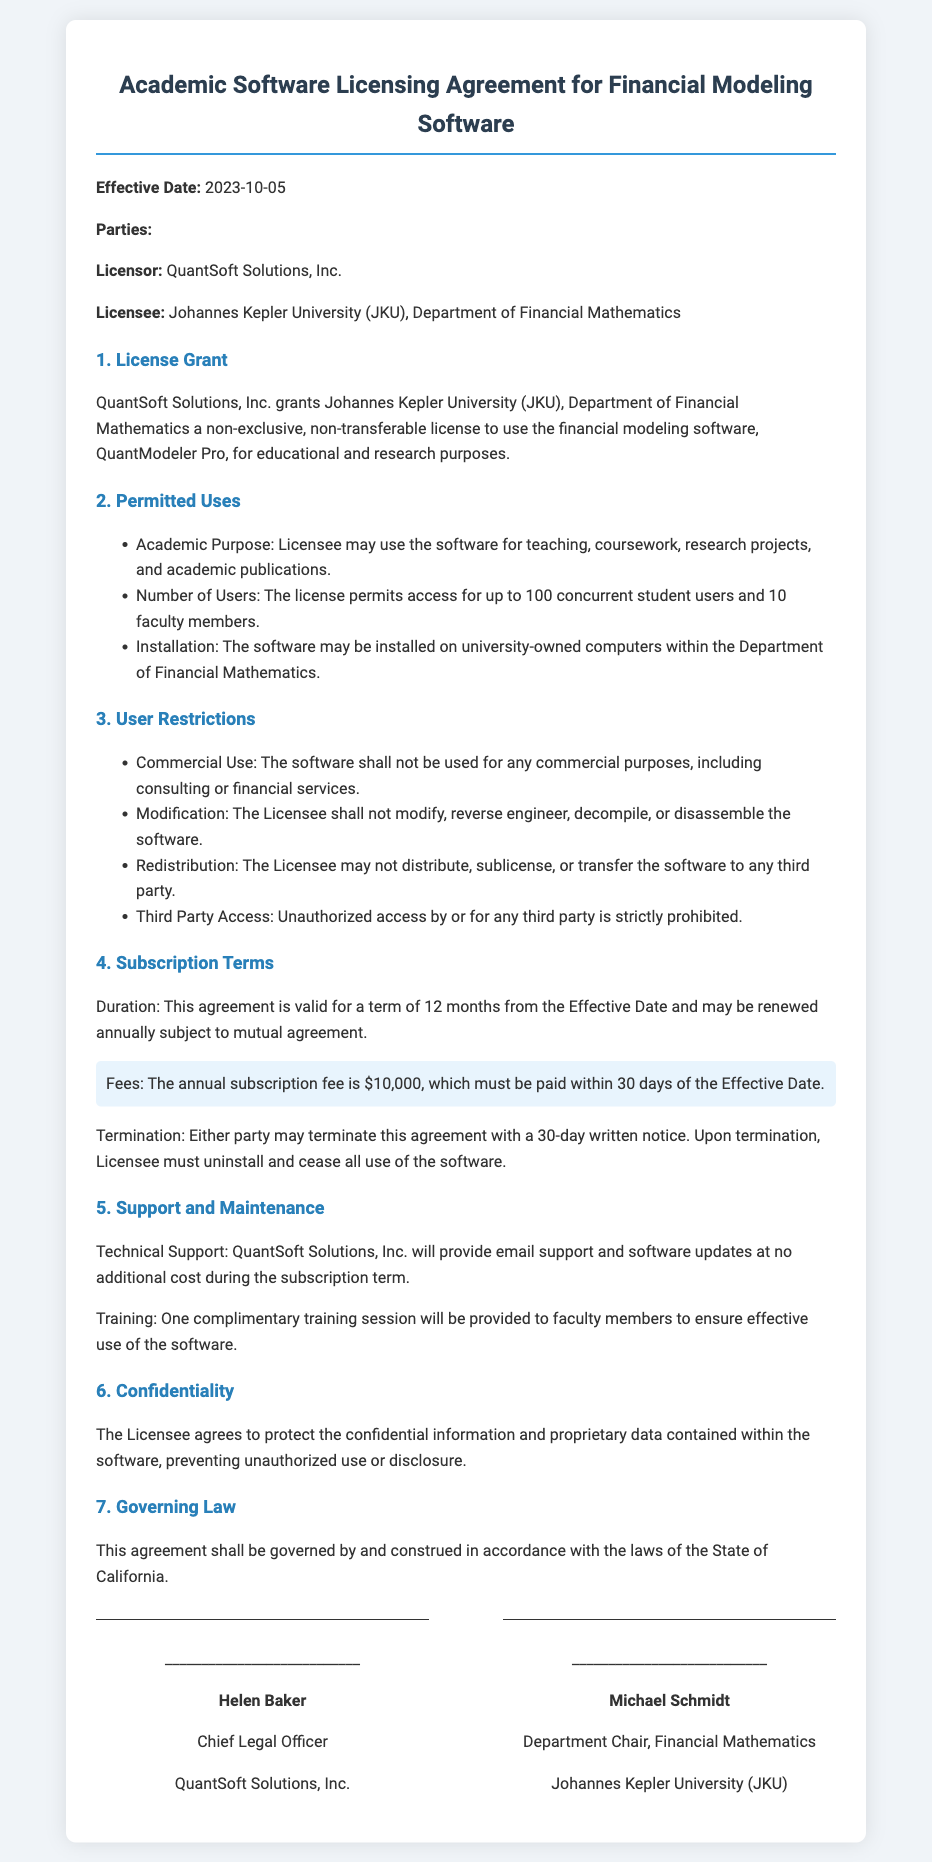What is the effective date of the agreement? The effective date is specified in the document under the "Effective Date" section.
Answer: 2023-10-05 Who is the licensor? The licensor is mentioned in the "Parties" section of the document.
Answer: QuantSoft Solutions, Inc How many concurrent student users can access the software? The document states the permitted number of users in the "Permitted Uses" section.
Answer: 100 What is the annual subscription fee? The annual subscription fee is detailed in the "Subscription Terms" section.
Answer: $10,000 What type of support will be provided during the subscription term? The "Support and Maintenance" section mentions the type of support offered.
Answer: Email support Can the software be used for commercial purposes? The "User Restrictions" section addresses the allowed uses of the software.
Answer: No How long is the term of the agreement? The duration of the agreement is specified in the "Subscription Terms" section.
Answer: 12 months What must the Licensee do upon termination of the agreement? The obligations upon termination are stated in the "Subscription Terms" section.
Answer: Uninstall and cease all use of the software Who will receive the complimentary training session? The "Support and Maintenance" section indicates who is entitled to training.
Answer: Faculty members 